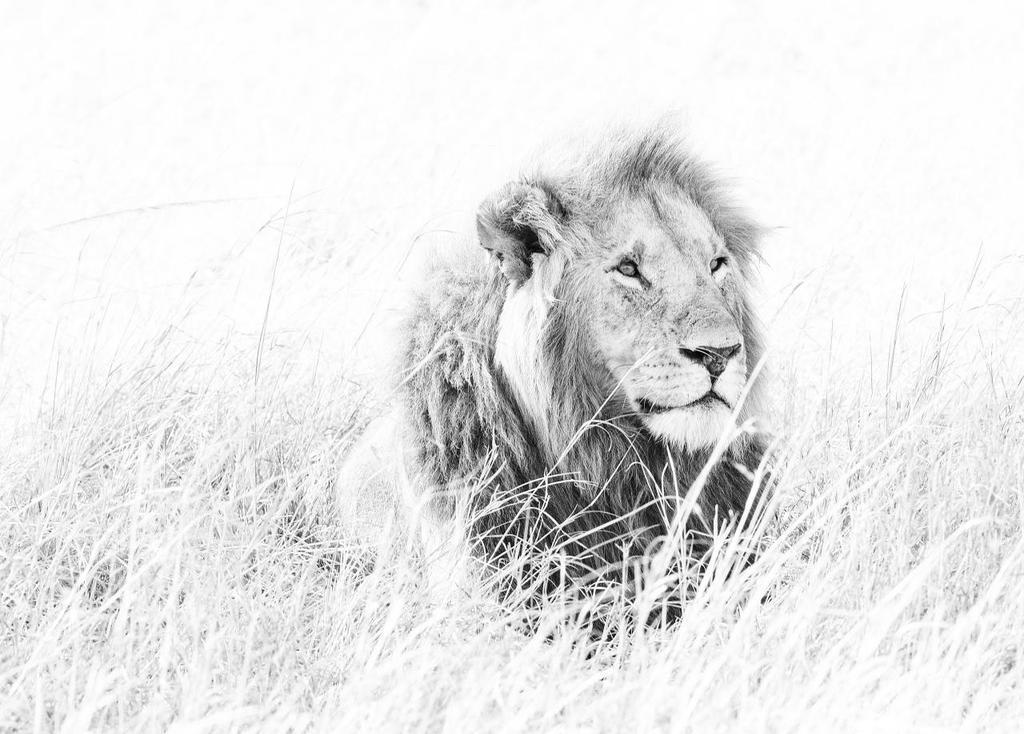Can you describe this image briefly? In this image we can see a lion. There is a grass in the image. 